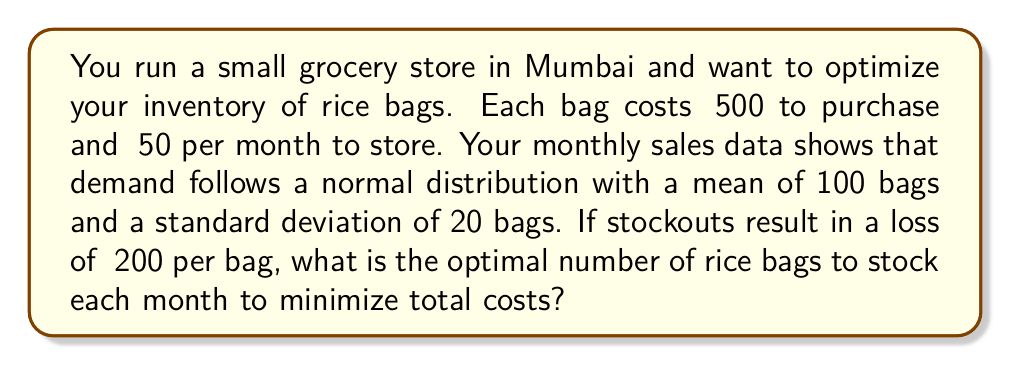Provide a solution to this math problem. To solve this problem, we'll use the newsvendor model, which is ideal for determining optimal inventory levels under uncertain demand. Let's follow these steps:

1. Define the variables:
   $c$ = cost per bag = ₹500
   $h$ = holding cost per bag per month = ₹50
   $p$ = stockout cost per bag = ₹200
   $\mu$ = mean demand = 100 bags
   $\sigma$ = standard deviation of demand = 20 bags

2. Calculate the critical fractile:
   $F^{-1}(z) = \frac{p}{p+h} = \frac{200}{200+50} = 0.8$

3. Find the z-score corresponding to the 0.8 fractile:
   Using a standard normal distribution table or calculator, we find $z \approx 0.84$

4. Calculate the optimal inventory level $Q^*$:
   $$Q^* = \mu + z\sigma = 100 + 0.84 \times 20 = 116.8$$

5. Round to the nearest whole number:
   Optimal inventory = 117 bags

This inventory level balances the cost of overstocking (holding costs) with the cost of understocking (lost sales and goodwill), minimizing the total expected costs.
Answer: 117 bags 